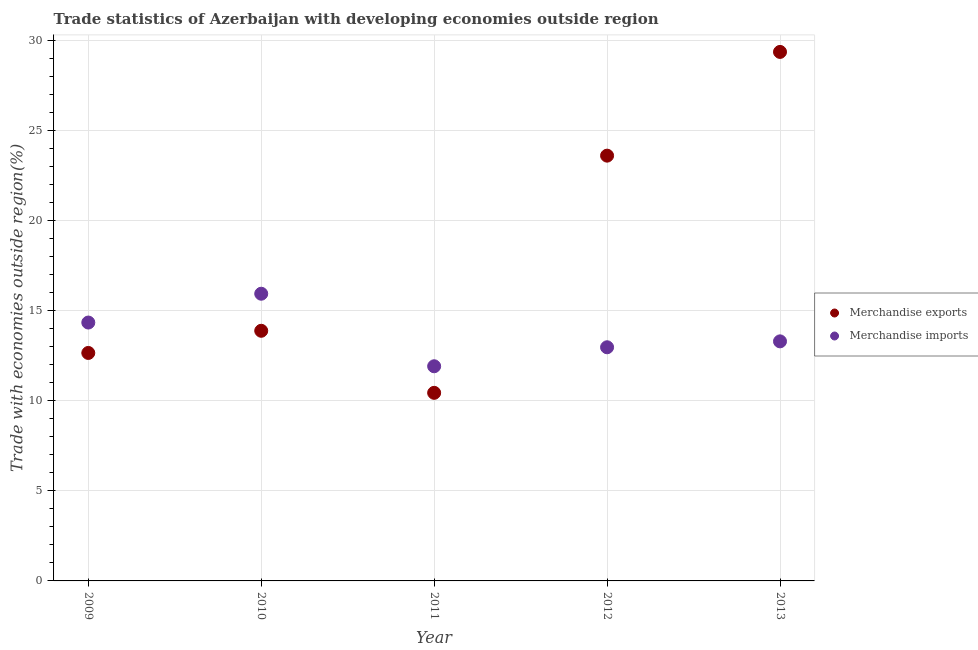How many different coloured dotlines are there?
Give a very brief answer. 2. Is the number of dotlines equal to the number of legend labels?
Provide a succinct answer. Yes. What is the merchandise exports in 2011?
Provide a succinct answer. 10.44. Across all years, what is the maximum merchandise imports?
Ensure brevity in your answer.  15.94. Across all years, what is the minimum merchandise imports?
Offer a terse response. 11.91. In which year was the merchandise imports maximum?
Offer a very short reply. 2010. What is the total merchandise exports in the graph?
Keep it short and to the point. 89.92. What is the difference between the merchandise exports in 2011 and that in 2012?
Provide a succinct answer. -13.16. What is the difference between the merchandise imports in 2010 and the merchandise exports in 2012?
Your response must be concise. -7.66. What is the average merchandise exports per year?
Ensure brevity in your answer.  17.98. In the year 2009, what is the difference between the merchandise exports and merchandise imports?
Offer a very short reply. -1.69. What is the ratio of the merchandise exports in 2009 to that in 2012?
Provide a succinct answer. 0.54. Is the merchandise exports in 2009 less than that in 2010?
Keep it short and to the point. Yes. What is the difference between the highest and the second highest merchandise imports?
Your response must be concise. 1.6. What is the difference between the highest and the lowest merchandise imports?
Give a very brief answer. 4.03. Is the merchandise exports strictly greater than the merchandise imports over the years?
Your answer should be very brief. No. How many dotlines are there?
Offer a very short reply. 2. What is the difference between two consecutive major ticks on the Y-axis?
Your answer should be compact. 5. Are the values on the major ticks of Y-axis written in scientific E-notation?
Keep it short and to the point. No. Does the graph contain any zero values?
Keep it short and to the point. No. Does the graph contain grids?
Make the answer very short. Yes. Where does the legend appear in the graph?
Offer a terse response. Center right. What is the title of the graph?
Give a very brief answer. Trade statistics of Azerbaijan with developing economies outside region. What is the label or title of the Y-axis?
Ensure brevity in your answer.  Trade with economies outside region(%). What is the Trade with economies outside region(%) in Merchandise exports in 2009?
Your response must be concise. 12.65. What is the Trade with economies outside region(%) in Merchandise imports in 2009?
Offer a terse response. 14.34. What is the Trade with economies outside region(%) of Merchandise exports in 2010?
Offer a very short reply. 13.88. What is the Trade with economies outside region(%) in Merchandise imports in 2010?
Ensure brevity in your answer.  15.94. What is the Trade with economies outside region(%) in Merchandise exports in 2011?
Give a very brief answer. 10.44. What is the Trade with economies outside region(%) in Merchandise imports in 2011?
Your answer should be very brief. 11.91. What is the Trade with economies outside region(%) of Merchandise exports in 2012?
Offer a terse response. 23.6. What is the Trade with economies outside region(%) in Merchandise imports in 2012?
Make the answer very short. 12.96. What is the Trade with economies outside region(%) of Merchandise exports in 2013?
Offer a very short reply. 29.35. What is the Trade with economies outside region(%) in Merchandise imports in 2013?
Offer a very short reply. 13.29. Across all years, what is the maximum Trade with economies outside region(%) in Merchandise exports?
Offer a very short reply. 29.35. Across all years, what is the maximum Trade with economies outside region(%) of Merchandise imports?
Provide a succinct answer. 15.94. Across all years, what is the minimum Trade with economies outside region(%) in Merchandise exports?
Make the answer very short. 10.44. Across all years, what is the minimum Trade with economies outside region(%) of Merchandise imports?
Keep it short and to the point. 11.91. What is the total Trade with economies outside region(%) of Merchandise exports in the graph?
Offer a very short reply. 89.92. What is the total Trade with economies outside region(%) in Merchandise imports in the graph?
Your answer should be compact. 68.44. What is the difference between the Trade with economies outside region(%) of Merchandise exports in 2009 and that in 2010?
Give a very brief answer. -1.23. What is the difference between the Trade with economies outside region(%) in Merchandise imports in 2009 and that in 2010?
Your answer should be very brief. -1.6. What is the difference between the Trade with economies outside region(%) in Merchandise exports in 2009 and that in 2011?
Ensure brevity in your answer.  2.21. What is the difference between the Trade with economies outside region(%) of Merchandise imports in 2009 and that in 2011?
Provide a succinct answer. 2.43. What is the difference between the Trade with economies outside region(%) in Merchandise exports in 2009 and that in 2012?
Provide a short and direct response. -10.95. What is the difference between the Trade with economies outside region(%) of Merchandise imports in 2009 and that in 2012?
Ensure brevity in your answer.  1.37. What is the difference between the Trade with economies outside region(%) in Merchandise exports in 2009 and that in 2013?
Your response must be concise. -16.7. What is the difference between the Trade with economies outside region(%) of Merchandise imports in 2009 and that in 2013?
Your answer should be compact. 1.04. What is the difference between the Trade with economies outside region(%) of Merchandise exports in 2010 and that in 2011?
Your answer should be very brief. 3.44. What is the difference between the Trade with economies outside region(%) of Merchandise imports in 2010 and that in 2011?
Provide a succinct answer. 4.03. What is the difference between the Trade with economies outside region(%) in Merchandise exports in 2010 and that in 2012?
Your response must be concise. -9.72. What is the difference between the Trade with economies outside region(%) in Merchandise imports in 2010 and that in 2012?
Make the answer very short. 2.97. What is the difference between the Trade with economies outside region(%) of Merchandise exports in 2010 and that in 2013?
Provide a short and direct response. -15.47. What is the difference between the Trade with economies outside region(%) in Merchandise imports in 2010 and that in 2013?
Make the answer very short. 2.64. What is the difference between the Trade with economies outside region(%) in Merchandise exports in 2011 and that in 2012?
Ensure brevity in your answer.  -13.16. What is the difference between the Trade with economies outside region(%) of Merchandise imports in 2011 and that in 2012?
Your answer should be compact. -1.05. What is the difference between the Trade with economies outside region(%) of Merchandise exports in 2011 and that in 2013?
Make the answer very short. -18.92. What is the difference between the Trade with economies outside region(%) of Merchandise imports in 2011 and that in 2013?
Your answer should be compact. -1.38. What is the difference between the Trade with economies outside region(%) in Merchandise exports in 2012 and that in 2013?
Make the answer very short. -5.76. What is the difference between the Trade with economies outside region(%) of Merchandise imports in 2012 and that in 2013?
Your response must be concise. -0.33. What is the difference between the Trade with economies outside region(%) in Merchandise exports in 2009 and the Trade with economies outside region(%) in Merchandise imports in 2010?
Ensure brevity in your answer.  -3.29. What is the difference between the Trade with economies outside region(%) of Merchandise exports in 2009 and the Trade with economies outside region(%) of Merchandise imports in 2011?
Give a very brief answer. 0.74. What is the difference between the Trade with economies outside region(%) in Merchandise exports in 2009 and the Trade with economies outside region(%) in Merchandise imports in 2012?
Your answer should be very brief. -0.32. What is the difference between the Trade with economies outside region(%) in Merchandise exports in 2009 and the Trade with economies outside region(%) in Merchandise imports in 2013?
Your response must be concise. -0.64. What is the difference between the Trade with economies outside region(%) of Merchandise exports in 2010 and the Trade with economies outside region(%) of Merchandise imports in 2011?
Ensure brevity in your answer.  1.97. What is the difference between the Trade with economies outside region(%) in Merchandise exports in 2010 and the Trade with economies outside region(%) in Merchandise imports in 2012?
Your answer should be compact. 0.91. What is the difference between the Trade with economies outside region(%) of Merchandise exports in 2010 and the Trade with economies outside region(%) of Merchandise imports in 2013?
Your answer should be compact. 0.59. What is the difference between the Trade with economies outside region(%) in Merchandise exports in 2011 and the Trade with economies outside region(%) in Merchandise imports in 2012?
Keep it short and to the point. -2.53. What is the difference between the Trade with economies outside region(%) of Merchandise exports in 2011 and the Trade with economies outside region(%) of Merchandise imports in 2013?
Provide a succinct answer. -2.86. What is the difference between the Trade with economies outside region(%) of Merchandise exports in 2012 and the Trade with economies outside region(%) of Merchandise imports in 2013?
Your answer should be compact. 10.3. What is the average Trade with economies outside region(%) in Merchandise exports per year?
Give a very brief answer. 17.98. What is the average Trade with economies outside region(%) in Merchandise imports per year?
Provide a short and direct response. 13.69. In the year 2009, what is the difference between the Trade with economies outside region(%) of Merchandise exports and Trade with economies outside region(%) of Merchandise imports?
Your answer should be very brief. -1.69. In the year 2010, what is the difference between the Trade with economies outside region(%) in Merchandise exports and Trade with economies outside region(%) in Merchandise imports?
Offer a terse response. -2.06. In the year 2011, what is the difference between the Trade with economies outside region(%) of Merchandise exports and Trade with economies outside region(%) of Merchandise imports?
Offer a terse response. -1.47. In the year 2012, what is the difference between the Trade with economies outside region(%) of Merchandise exports and Trade with economies outside region(%) of Merchandise imports?
Provide a succinct answer. 10.63. In the year 2013, what is the difference between the Trade with economies outside region(%) of Merchandise exports and Trade with economies outside region(%) of Merchandise imports?
Your response must be concise. 16.06. What is the ratio of the Trade with economies outside region(%) in Merchandise exports in 2009 to that in 2010?
Ensure brevity in your answer.  0.91. What is the ratio of the Trade with economies outside region(%) in Merchandise imports in 2009 to that in 2010?
Provide a short and direct response. 0.9. What is the ratio of the Trade with economies outside region(%) of Merchandise exports in 2009 to that in 2011?
Offer a very short reply. 1.21. What is the ratio of the Trade with economies outside region(%) in Merchandise imports in 2009 to that in 2011?
Offer a terse response. 1.2. What is the ratio of the Trade with economies outside region(%) in Merchandise exports in 2009 to that in 2012?
Your answer should be compact. 0.54. What is the ratio of the Trade with economies outside region(%) in Merchandise imports in 2009 to that in 2012?
Your response must be concise. 1.11. What is the ratio of the Trade with economies outside region(%) in Merchandise exports in 2009 to that in 2013?
Ensure brevity in your answer.  0.43. What is the ratio of the Trade with economies outside region(%) in Merchandise imports in 2009 to that in 2013?
Offer a very short reply. 1.08. What is the ratio of the Trade with economies outside region(%) in Merchandise exports in 2010 to that in 2011?
Ensure brevity in your answer.  1.33. What is the ratio of the Trade with economies outside region(%) of Merchandise imports in 2010 to that in 2011?
Ensure brevity in your answer.  1.34. What is the ratio of the Trade with economies outside region(%) in Merchandise exports in 2010 to that in 2012?
Give a very brief answer. 0.59. What is the ratio of the Trade with economies outside region(%) in Merchandise imports in 2010 to that in 2012?
Your answer should be compact. 1.23. What is the ratio of the Trade with economies outside region(%) of Merchandise exports in 2010 to that in 2013?
Your answer should be very brief. 0.47. What is the ratio of the Trade with economies outside region(%) of Merchandise imports in 2010 to that in 2013?
Give a very brief answer. 1.2. What is the ratio of the Trade with economies outside region(%) of Merchandise exports in 2011 to that in 2012?
Give a very brief answer. 0.44. What is the ratio of the Trade with economies outside region(%) of Merchandise imports in 2011 to that in 2012?
Offer a very short reply. 0.92. What is the ratio of the Trade with economies outside region(%) of Merchandise exports in 2011 to that in 2013?
Provide a succinct answer. 0.36. What is the ratio of the Trade with economies outside region(%) in Merchandise imports in 2011 to that in 2013?
Give a very brief answer. 0.9. What is the ratio of the Trade with economies outside region(%) of Merchandise exports in 2012 to that in 2013?
Ensure brevity in your answer.  0.8. What is the ratio of the Trade with economies outside region(%) in Merchandise imports in 2012 to that in 2013?
Make the answer very short. 0.98. What is the difference between the highest and the second highest Trade with economies outside region(%) in Merchandise exports?
Make the answer very short. 5.76. What is the difference between the highest and the second highest Trade with economies outside region(%) in Merchandise imports?
Your answer should be very brief. 1.6. What is the difference between the highest and the lowest Trade with economies outside region(%) of Merchandise exports?
Offer a terse response. 18.92. What is the difference between the highest and the lowest Trade with economies outside region(%) in Merchandise imports?
Give a very brief answer. 4.03. 